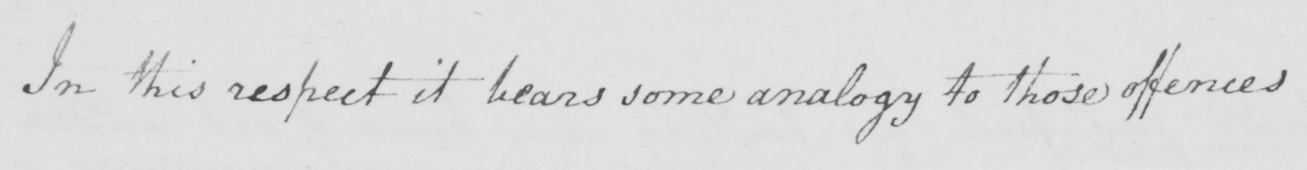What text is written in this handwritten line? In this respect it bears some analogy to those offences 